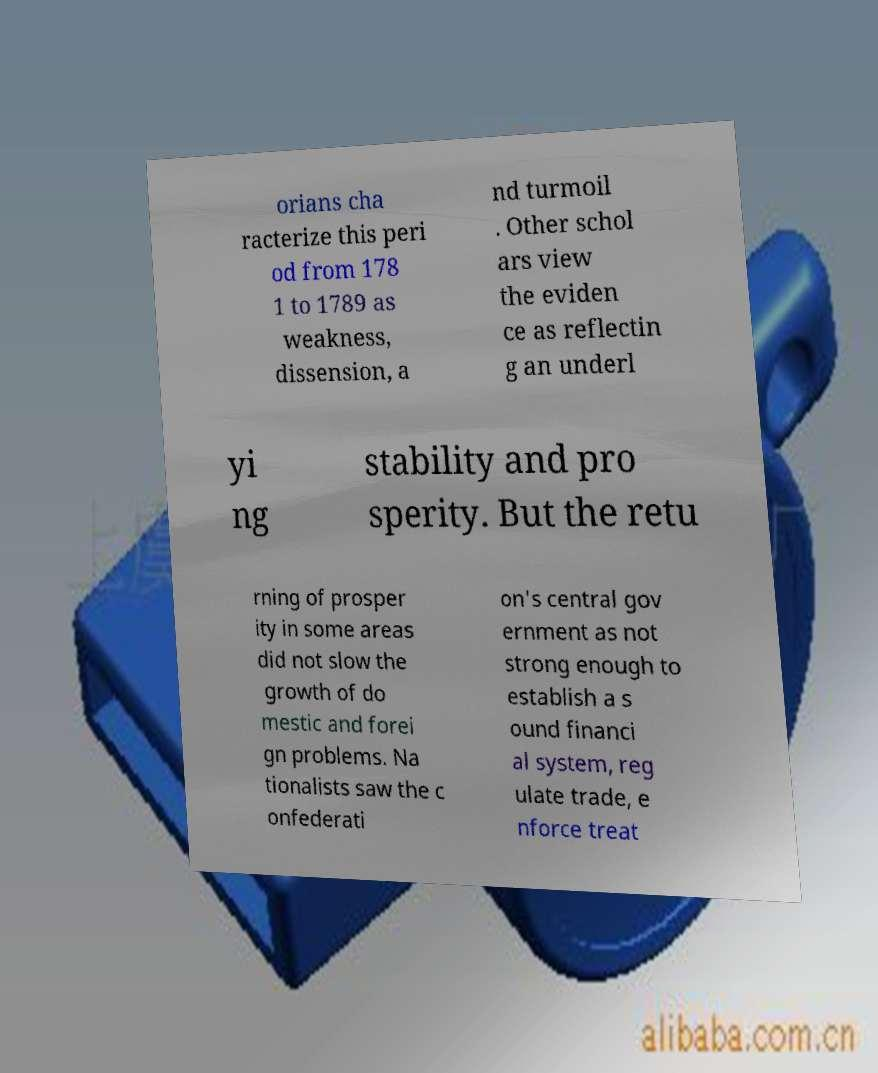I need the written content from this picture converted into text. Can you do that? orians cha racterize this peri od from 178 1 to 1789 as weakness, dissension, a nd turmoil . Other schol ars view the eviden ce as reflectin g an underl yi ng stability and pro sperity. But the retu rning of prosper ity in some areas did not slow the growth of do mestic and forei gn problems. Na tionalists saw the c onfederati on's central gov ernment as not strong enough to establish a s ound financi al system, reg ulate trade, e nforce treat 